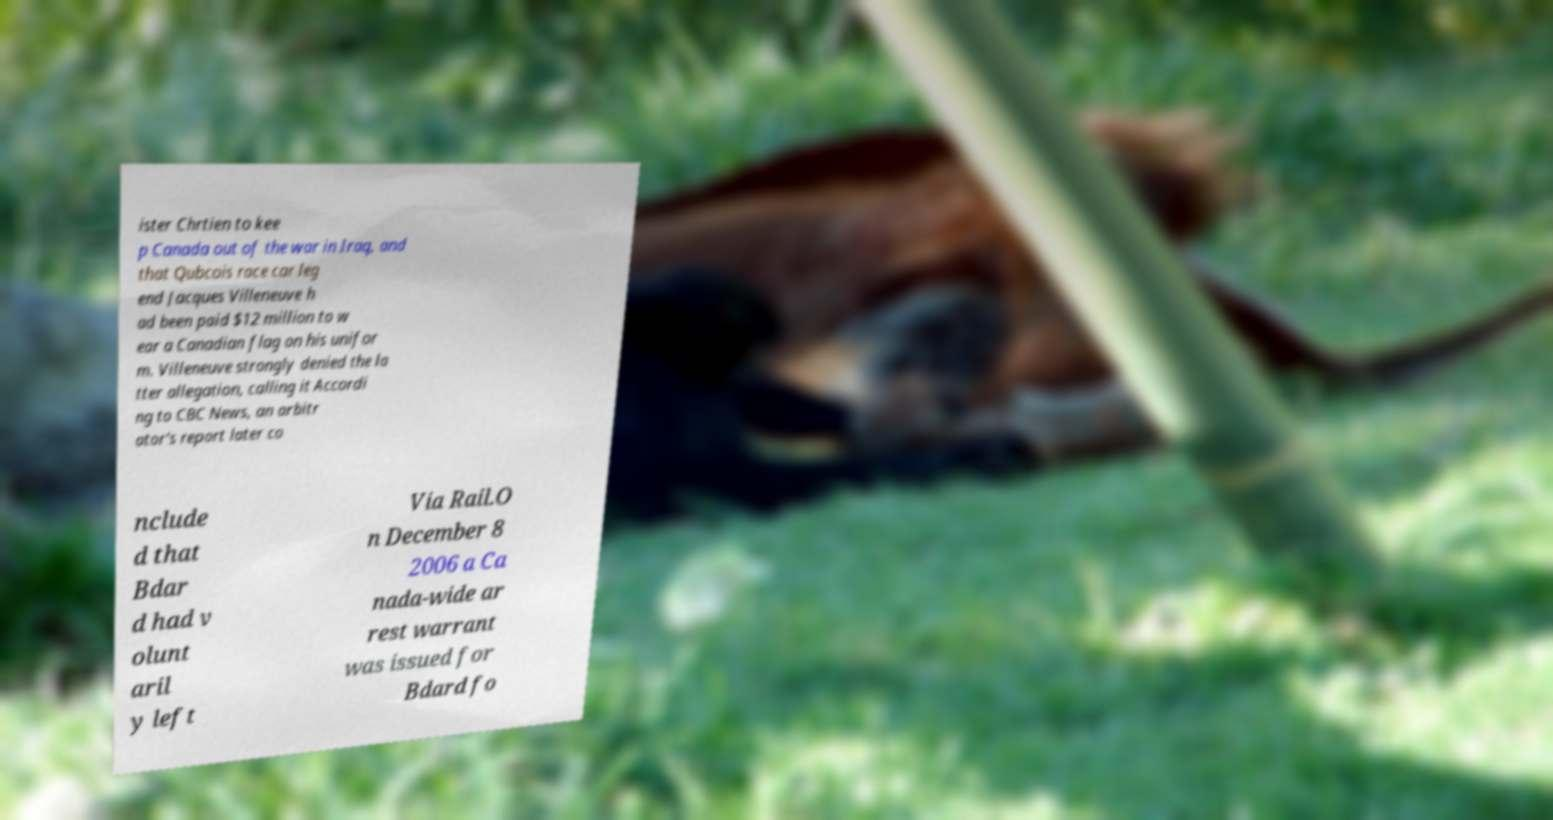For documentation purposes, I need the text within this image transcribed. Could you provide that? ister Chrtien to kee p Canada out of the war in Iraq, and that Qubcois race car leg end Jacques Villeneuve h ad been paid $12 million to w ear a Canadian flag on his unifor m. Villeneuve strongly denied the la tter allegation, calling it Accordi ng to CBC News, an arbitr ator's report later co nclude d that Bdar d had v olunt aril y left Via Rail.O n December 8 2006 a Ca nada-wide ar rest warrant was issued for Bdard fo 